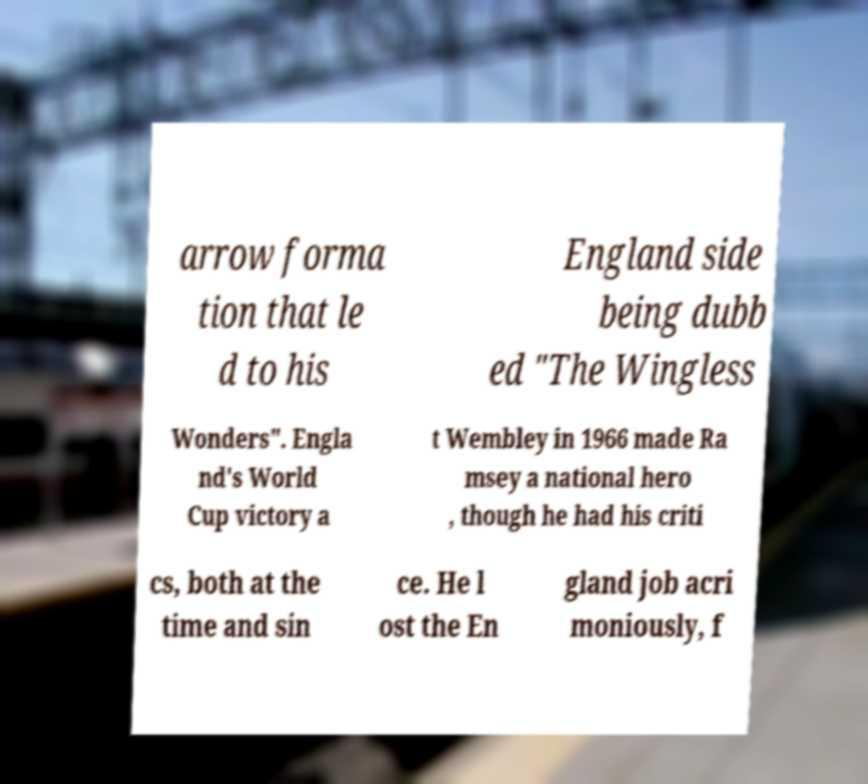There's text embedded in this image that I need extracted. Can you transcribe it verbatim? arrow forma tion that le d to his England side being dubb ed "The Wingless Wonders". Engla nd's World Cup victory a t Wembley in 1966 made Ra msey a national hero , though he had his criti cs, both at the time and sin ce. He l ost the En gland job acri moniously, f 